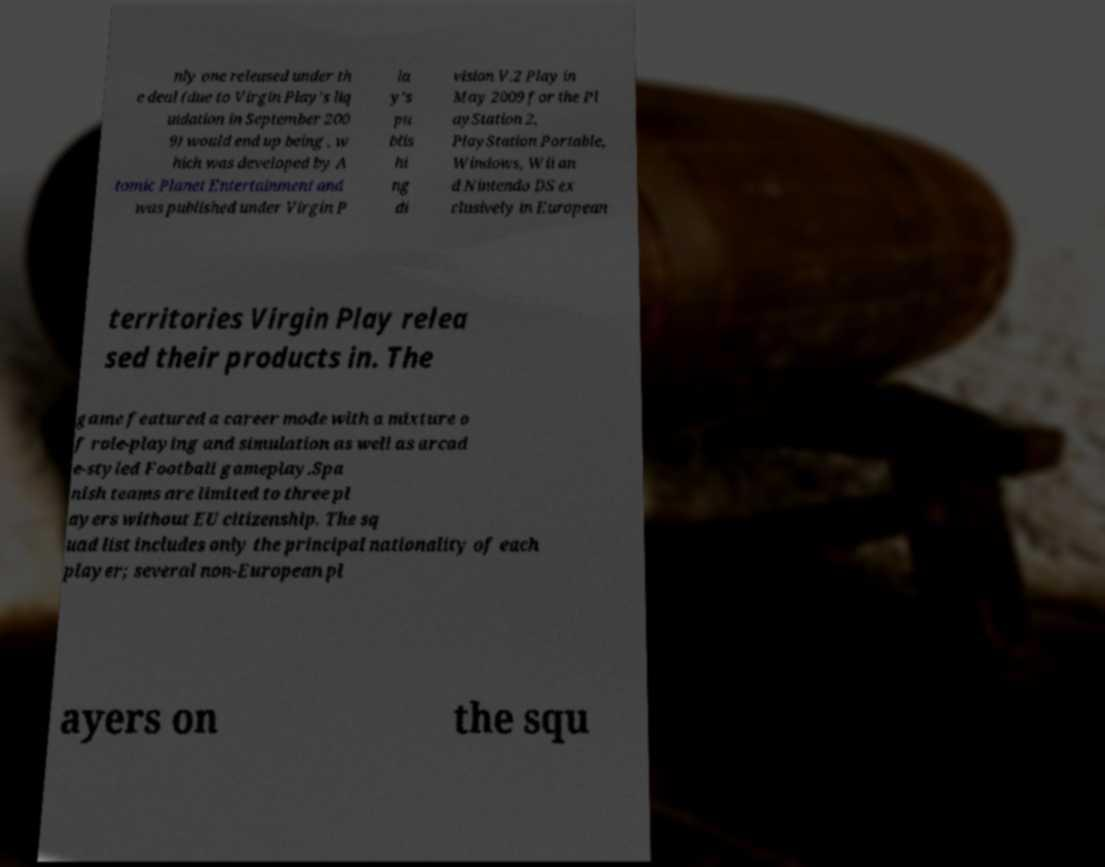Can you accurately transcribe the text from the provided image for me? nly one released under th e deal (due to Virgin Play's liq uidation in September 200 9) would end up being , w hich was developed by A tomic Planet Entertainment and was published under Virgin P la y's pu blis hi ng di vision V.2 Play in May 2009 for the Pl ayStation 2, PlayStation Portable, Windows, Wii an d Nintendo DS ex clusively in European territories Virgin Play relea sed their products in. The game featured a career mode with a mixture o f role-playing and simulation as well as arcad e-styled Football gameplay.Spa nish teams are limited to three pl ayers without EU citizenship. The sq uad list includes only the principal nationality of each player; several non-European pl ayers on the squ 